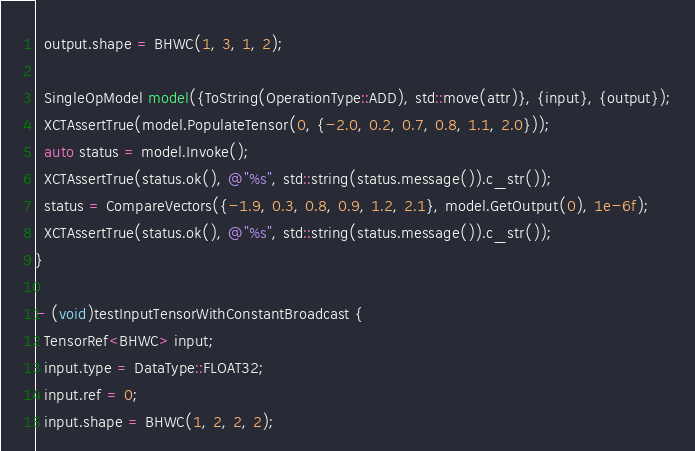<code> <loc_0><loc_0><loc_500><loc_500><_ObjectiveC_>  output.shape = BHWC(1, 3, 1, 2);

  SingleOpModel model({ToString(OperationType::ADD), std::move(attr)}, {input}, {output});
  XCTAssertTrue(model.PopulateTensor(0, {-2.0, 0.2, 0.7, 0.8, 1.1, 2.0}));
  auto status = model.Invoke();
  XCTAssertTrue(status.ok(), @"%s", std::string(status.message()).c_str());
  status = CompareVectors({-1.9, 0.3, 0.8, 0.9, 1.2, 2.1}, model.GetOutput(0), 1e-6f);
  XCTAssertTrue(status.ok(), @"%s", std::string(status.message()).c_str());
}

- (void)testInputTensorWithConstantBroadcast {
  TensorRef<BHWC> input;
  input.type = DataType::FLOAT32;
  input.ref = 0;
  input.shape = BHWC(1, 2, 2, 2);
</code> 